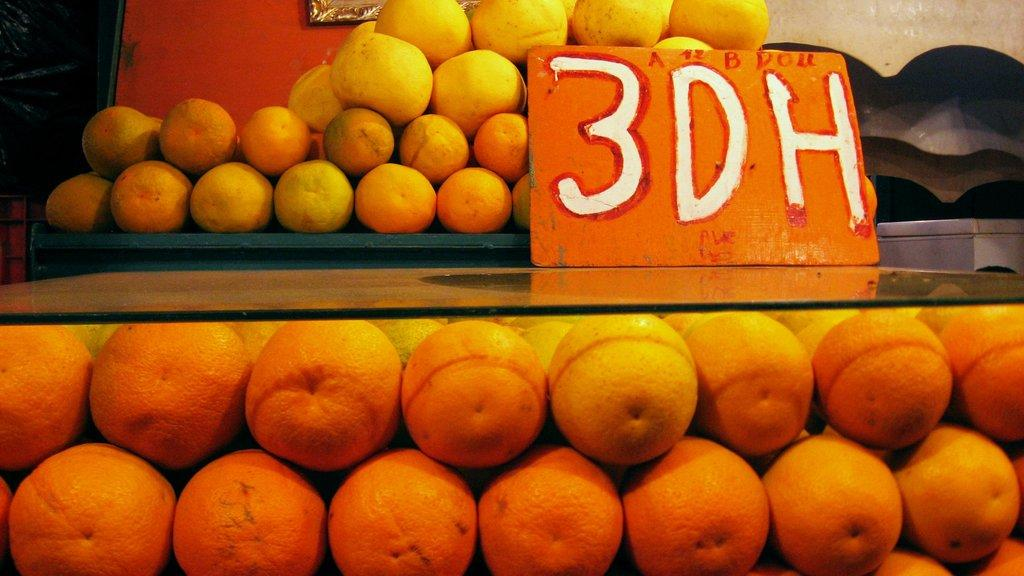What type of fruit is at the bottom of the image? There are oranges at the bottom of the image. What else can be seen in the image besides the oranges? There is a small board with text in the image. Does the image have any borders or edges? Yes, the image appears to have a frame. What is located at the top of the image? There are fruits at the top of the image. What type of mailbox is present in the image? There is no mailbox present in the image. Can you describe the kitty playing with the fruits in the image? There is no kitty present in the image; it only features oranges, a small board with text, and other fruits. 